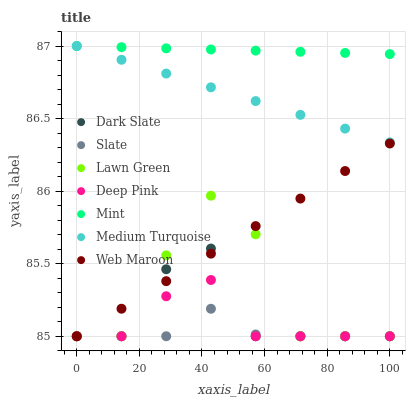Does Slate have the minimum area under the curve?
Answer yes or no. Yes. Does Mint have the maximum area under the curve?
Answer yes or no. Yes. Does Deep Pink have the minimum area under the curve?
Answer yes or no. No. Does Deep Pink have the maximum area under the curve?
Answer yes or no. No. Is Web Maroon the smoothest?
Answer yes or no. Yes. Is Lawn Green the roughest?
Answer yes or no. Yes. Is Deep Pink the smoothest?
Answer yes or no. No. Is Deep Pink the roughest?
Answer yes or no. No. Does Lawn Green have the lowest value?
Answer yes or no. Yes. Does Medium Turquoise have the lowest value?
Answer yes or no. No. Does Mint have the highest value?
Answer yes or no. Yes. Does Deep Pink have the highest value?
Answer yes or no. No. Is Deep Pink less than Mint?
Answer yes or no. Yes. Is Mint greater than Dark Slate?
Answer yes or no. Yes. Does Slate intersect Dark Slate?
Answer yes or no. Yes. Is Slate less than Dark Slate?
Answer yes or no. No. Is Slate greater than Dark Slate?
Answer yes or no. No. Does Deep Pink intersect Mint?
Answer yes or no. No. 